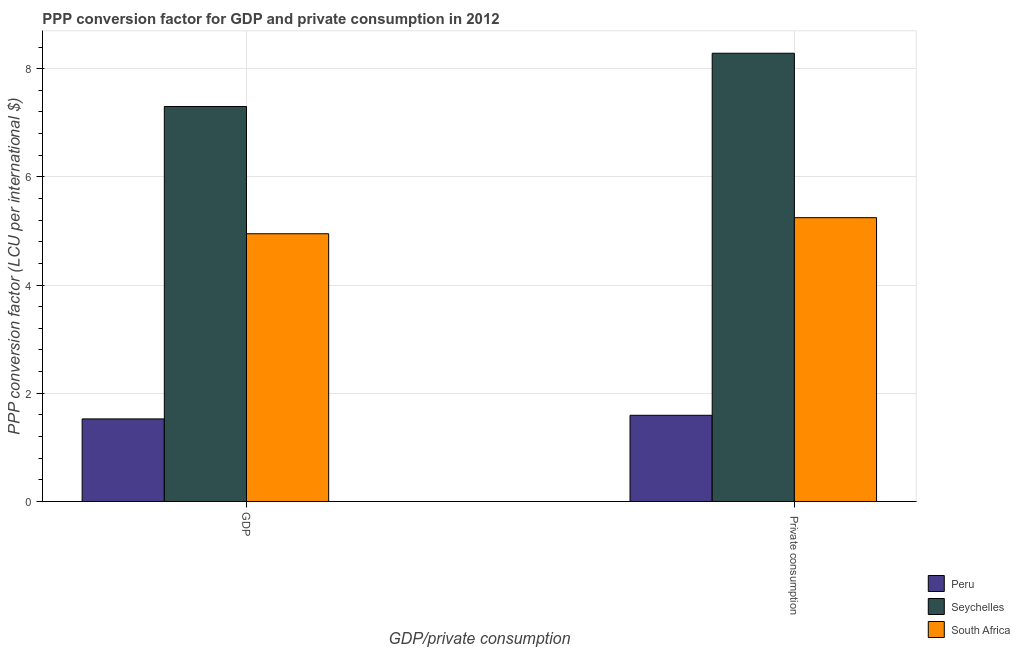How many different coloured bars are there?
Make the answer very short. 3. How many groups of bars are there?
Give a very brief answer. 2. Are the number of bars per tick equal to the number of legend labels?
Provide a succinct answer. Yes. Are the number of bars on each tick of the X-axis equal?
Your response must be concise. Yes. What is the label of the 2nd group of bars from the left?
Your answer should be very brief.  Private consumption. What is the ppp conversion factor for private consumption in Peru?
Your response must be concise. 1.59. Across all countries, what is the maximum ppp conversion factor for private consumption?
Make the answer very short. 8.29. Across all countries, what is the minimum ppp conversion factor for gdp?
Your answer should be very brief. 1.53. In which country was the ppp conversion factor for private consumption maximum?
Ensure brevity in your answer.  Seychelles. In which country was the ppp conversion factor for private consumption minimum?
Provide a short and direct response. Peru. What is the total ppp conversion factor for private consumption in the graph?
Give a very brief answer. 15.12. What is the difference between the ppp conversion factor for gdp in Peru and that in South Africa?
Offer a very short reply. -3.42. What is the difference between the ppp conversion factor for gdp in Seychelles and the ppp conversion factor for private consumption in South Africa?
Ensure brevity in your answer.  2.06. What is the average ppp conversion factor for gdp per country?
Offer a terse response. 4.59. What is the difference between the ppp conversion factor for gdp and ppp conversion factor for private consumption in South Africa?
Provide a short and direct response. -0.3. In how many countries, is the ppp conversion factor for private consumption greater than 6 LCU?
Provide a succinct answer. 1. What is the ratio of the ppp conversion factor for private consumption in South Africa to that in Peru?
Keep it short and to the point. 3.29. In how many countries, is the ppp conversion factor for private consumption greater than the average ppp conversion factor for private consumption taken over all countries?
Give a very brief answer. 2. What does the 1st bar from the left in  Private consumption represents?
Make the answer very short. Peru. What does the 1st bar from the right in GDP represents?
Offer a terse response. South Africa. How many bars are there?
Provide a short and direct response. 6. Are all the bars in the graph horizontal?
Give a very brief answer. No. How many countries are there in the graph?
Keep it short and to the point. 3. What is the difference between two consecutive major ticks on the Y-axis?
Ensure brevity in your answer.  2. Does the graph contain any zero values?
Offer a very short reply. No. Does the graph contain grids?
Your answer should be very brief. Yes. What is the title of the graph?
Ensure brevity in your answer.  PPP conversion factor for GDP and private consumption in 2012. What is the label or title of the X-axis?
Your response must be concise. GDP/private consumption. What is the label or title of the Y-axis?
Give a very brief answer. PPP conversion factor (LCU per international $). What is the PPP conversion factor (LCU per international $) of Peru in GDP?
Keep it short and to the point. 1.53. What is the PPP conversion factor (LCU per international $) in Seychelles in GDP?
Make the answer very short. 7.3. What is the PPP conversion factor (LCU per international $) of South Africa in GDP?
Your answer should be very brief. 4.95. What is the PPP conversion factor (LCU per international $) of Peru in  Private consumption?
Provide a short and direct response. 1.59. What is the PPP conversion factor (LCU per international $) in Seychelles in  Private consumption?
Your answer should be compact. 8.29. What is the PPP conversion factor (LCU per international $) in South Africa in  Private consumption?
Offer a terse response. 5.25. Across all GDP/private consumption, what is the maximum PPP conversion factor (LCU per international $) of Peru?
Ensure brevity in your answer.  1.59. Across all GDP/private consumption, what is the maximum PPP conversion factor (LCU per international $) in Seychelles?
Make the answer very short. 8.29. Across all GDP/private consumption, what is the maximum PPP conversion factor (LCU per international $) in South Africa?
Provide a succinct answer. 5.25. Across all GDP/private consumption, what is the minimum PPP conversion factor (LCU per international $) of Peru?
Provide a succinct answer. 1.53. Across all GDP/private consumption, what is the minimum PPP conversion factor (LCU per international $) in Seychelles?
Offer a terse response. 7.3. Across all GDP/private consumption, what is the minimum PPP conversion factor (LCU per international $) of South Africa?
Your answer should be compact. 4.95. What is the total PPP conversion factor (LCU per international $) of Peru in the graph?
Offer a very short reply. 3.12. What is the total PPP conversion factor (LCU per international $) in Seychelles in the graph?
Your answer should be very brief. 15.59. What is the total PPP conversion factor (LCU per international $) in South Africa in the graph?
Ensure brevity in your answer.  10.19. What is the difference between the PPP conversion factor (LCU per international $) in Peru in GDP and that in  Private consumption?
Offer a very short reply. -0.07. What is the difference between the PPP conversion factor (LCU per international $) of Seychelles in GDP and that in  Private consumption?
Provide a succinct answer. -0.98. What is the difference between the PPP conversion factor (LCU per international $) of South Africa in GDP and that in  Private consumption?
Provide a succinct answer. -0.3. What is the difference between the PPP conversion factor (LCU per international $) in Peru in GDP and the PPP conversion factor (LCU per international $) in Seychelles in  Private consumption?
Your response must be concise. -6.76. What is the difference between the PPP conversion factor (LCU per international $) in Peru in GDP and the PPP conversion factor (LCU per international $) in South Africa in  Private consumption?
Make the answer very short. -3.72. What is the difference between the PPP conversion factor (LCU per international $) of Seychelles in GDP and the PPP conversion factor (LCU per international $) of South Africa in  Private consumption?
Give a very brief answer. 2.06. What is the average PPP conversion factor (LCU per international $) of Peru per GDP/private consumption?
Your response must be concise. 1.56. What is the average PPP conversion factor (LCU per international $) of Seychelles per GDP/private consumption?
Keep it short and to the point. 7.79. What is the average PPP conversion factor (LCU per international $) of South Africa per GDP/private consumption?
Provide a succinct answer. 5.1. What is the difference between the PPP conversion factor (LCU per international $) of Peru and PPP conversion factor (LCU per international $) of Seychelles in GDP?
Provide a succinct answer. -5.77. What is the difference between the PPP conversion factor (LCU per international $) in Peru and PPP conversion factor (LCU per international $) in South Africa in GDP?
Give a very brief answer. -3.42. What is the difference between the PPP conversion factor (LCU per international $) in Seychelles and PPP conversion factor (LCU per international $) in South Africa in GDP?
Give a very brief answer. 2.35. What is the difference between the PPP conversion factor (LCU per international $) of Peru and PPP conversion factor (LCU per international $) of Seychelles in  Private consumption?
Keep it short and to the point. -6.69. What is the difference between the PPP conversion factor (LCU per international $) of Peru and PPP conversion factor (LCU per international $) of South Africa in  Private consumption?
Offer a very short reply. -3.65. What is the difference between the PPP conversion factor (LCU per international $) of Seychelles and PPP conversion factor (LCU per international $) of South Africa in  Private consumption?
Ensure brevity in your answer.  3.04. What is the ratio of the PPP conversion factor (LCU per international $) in Peru in GDP to that in  Private consumption?
Ensure brevity in your answer.  0.96. What is the ratio of the PPP conversion factor (LCU per international $) in Seychelles in GDP to that in  Private consumption?
Your answer should be compact. 0.88. What is the ratio of the PPP conversion factor (LCU per international $) of South Africa in GDP to that in  Private consumption?
Give a very brief answer. 0.94. What is the difference between the highest and the second highest PPP conversion factor (LCU per international $) of Peru?
Make the answer very short. 0.07. What is the difference between the highest and the second highest PPP conversion factor (LCU per international $) in Seychelles?
Your answer should be compact. 0.98. What is the difference between the highest and the second highest PPP conversion factor (LCU per international $) in South Africa?
Keep it short and to the point. 0.3. What is the difference between the highest and the lowest PPP conversion factor (LCU per international $) in Peru?
Provide a short and direct response. 0.07. What is the difference between the highest and the lowest PPP conversion factor (LCU per international $) of Seychelles?
Your answer should be compact. 0.98. What is the difference between the highest and the lowest PPP conversion factor (LCU per international $) of South Africa?
Your response must be concise. 0.3. 